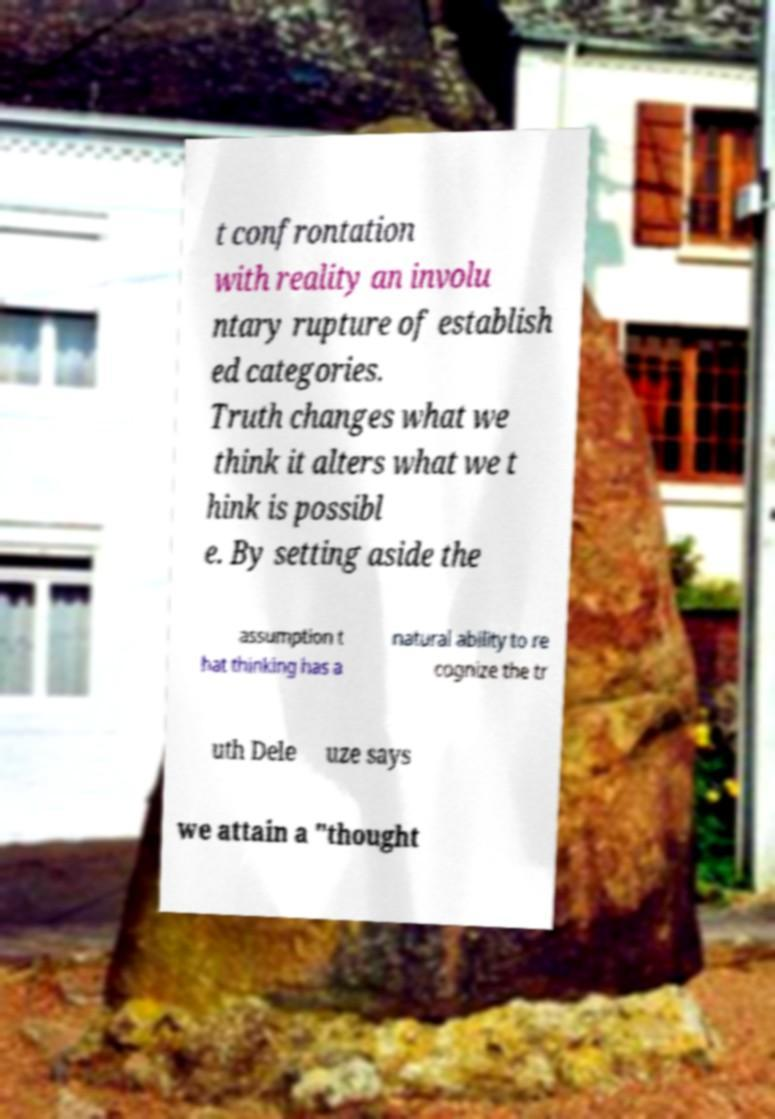What messages or text are displayed in this image? I need them in a readable, typed format. t confrontation with reality an involu ntary rupture of establish ed categories. Truth changes what we think it alters what we t hink is possibl e. By setting aside the assumption t hat thinking has a natural ability to re cognize the tr uth Dele uze says we attain a "thought 